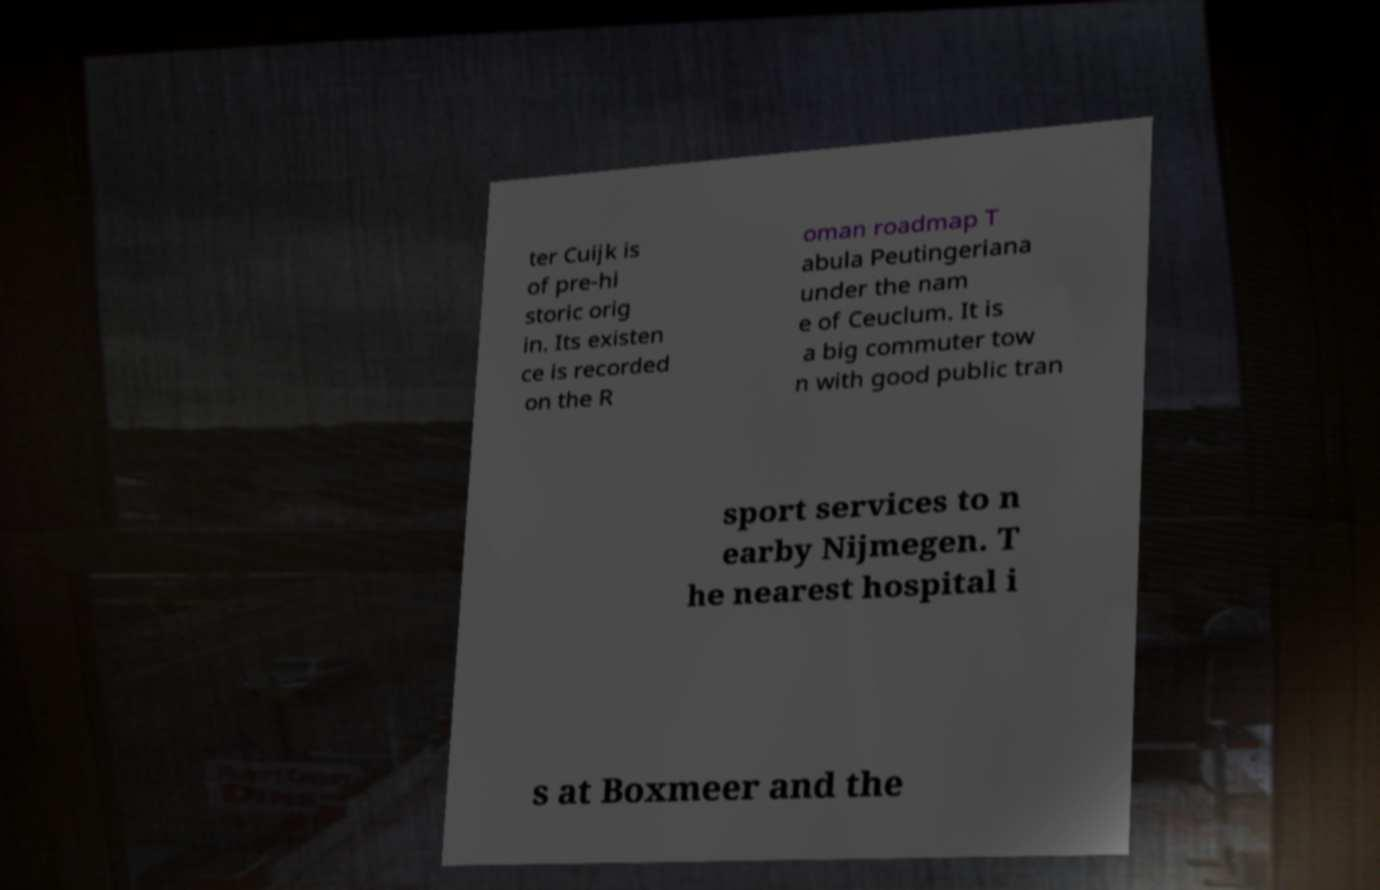For documentation purposes, I need the text within this image transcribed. Could you provide that? ter Cuijk is of pre-hi storic orig in. Its existen ce is recorded on the R oman roadmap T abula Peutingeriana under the nam e of Ceuclum. It is a big commuter tow n with good public tran sport services to n earby Nijmegen. T he nearest hospital i s at Boxmeer and the 